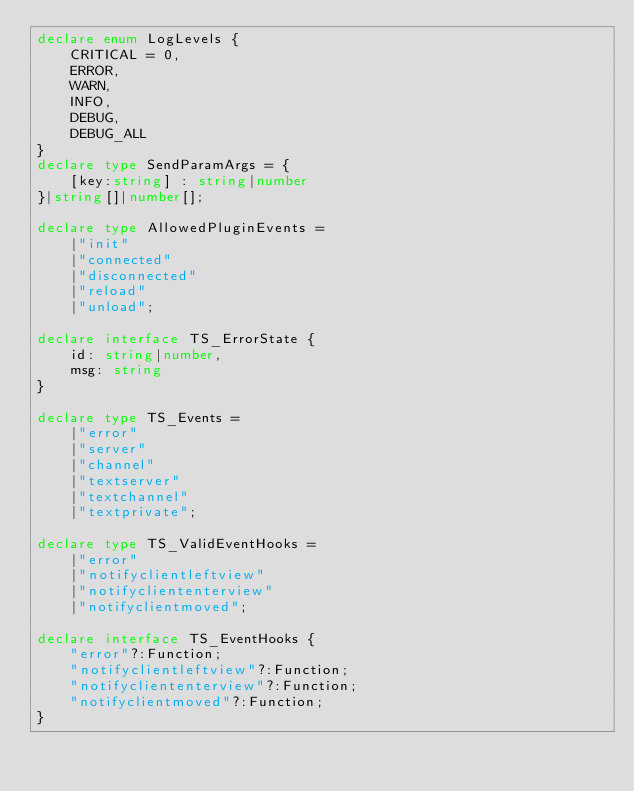<code> <loc_0><loc_0><loc_500><loc_500><_TypeScript_>declare enum LogLevels {
    CRITICAL = 0,
    ERROR,
    WARN,
    INFO,
    DEBUG,
    DEBUG_ALL
}
declare type SendParamArgs = {
    [key:string] : string|number
}|string[]|number[];

declare type AllowedPluginEvents = 
    |"init"
    |"connected"
    |"disconnected"
    |"reload"
    |"unload";

declare interface TS_ErrorState {
    id: string|number,
    msg: string
}

declare type TS_Events = 
    |"error"
    |"server"
    |"channel"
    |"textserver"
    |"textchannel"
    |"textprivate";

declare type TS_ValidEventHooks = 
    |"error"
    |"notifyclientleftview"
    |"notifycliententerview"
    |"notifyclientmoved";

declare interface TS_EventHooks {
    "error"?:Function;
    "notifyclientleftview"?:Function;
    "notifycliententerview"?:Function;
    "notifyclientmoved"?:Function;
}
</code> 